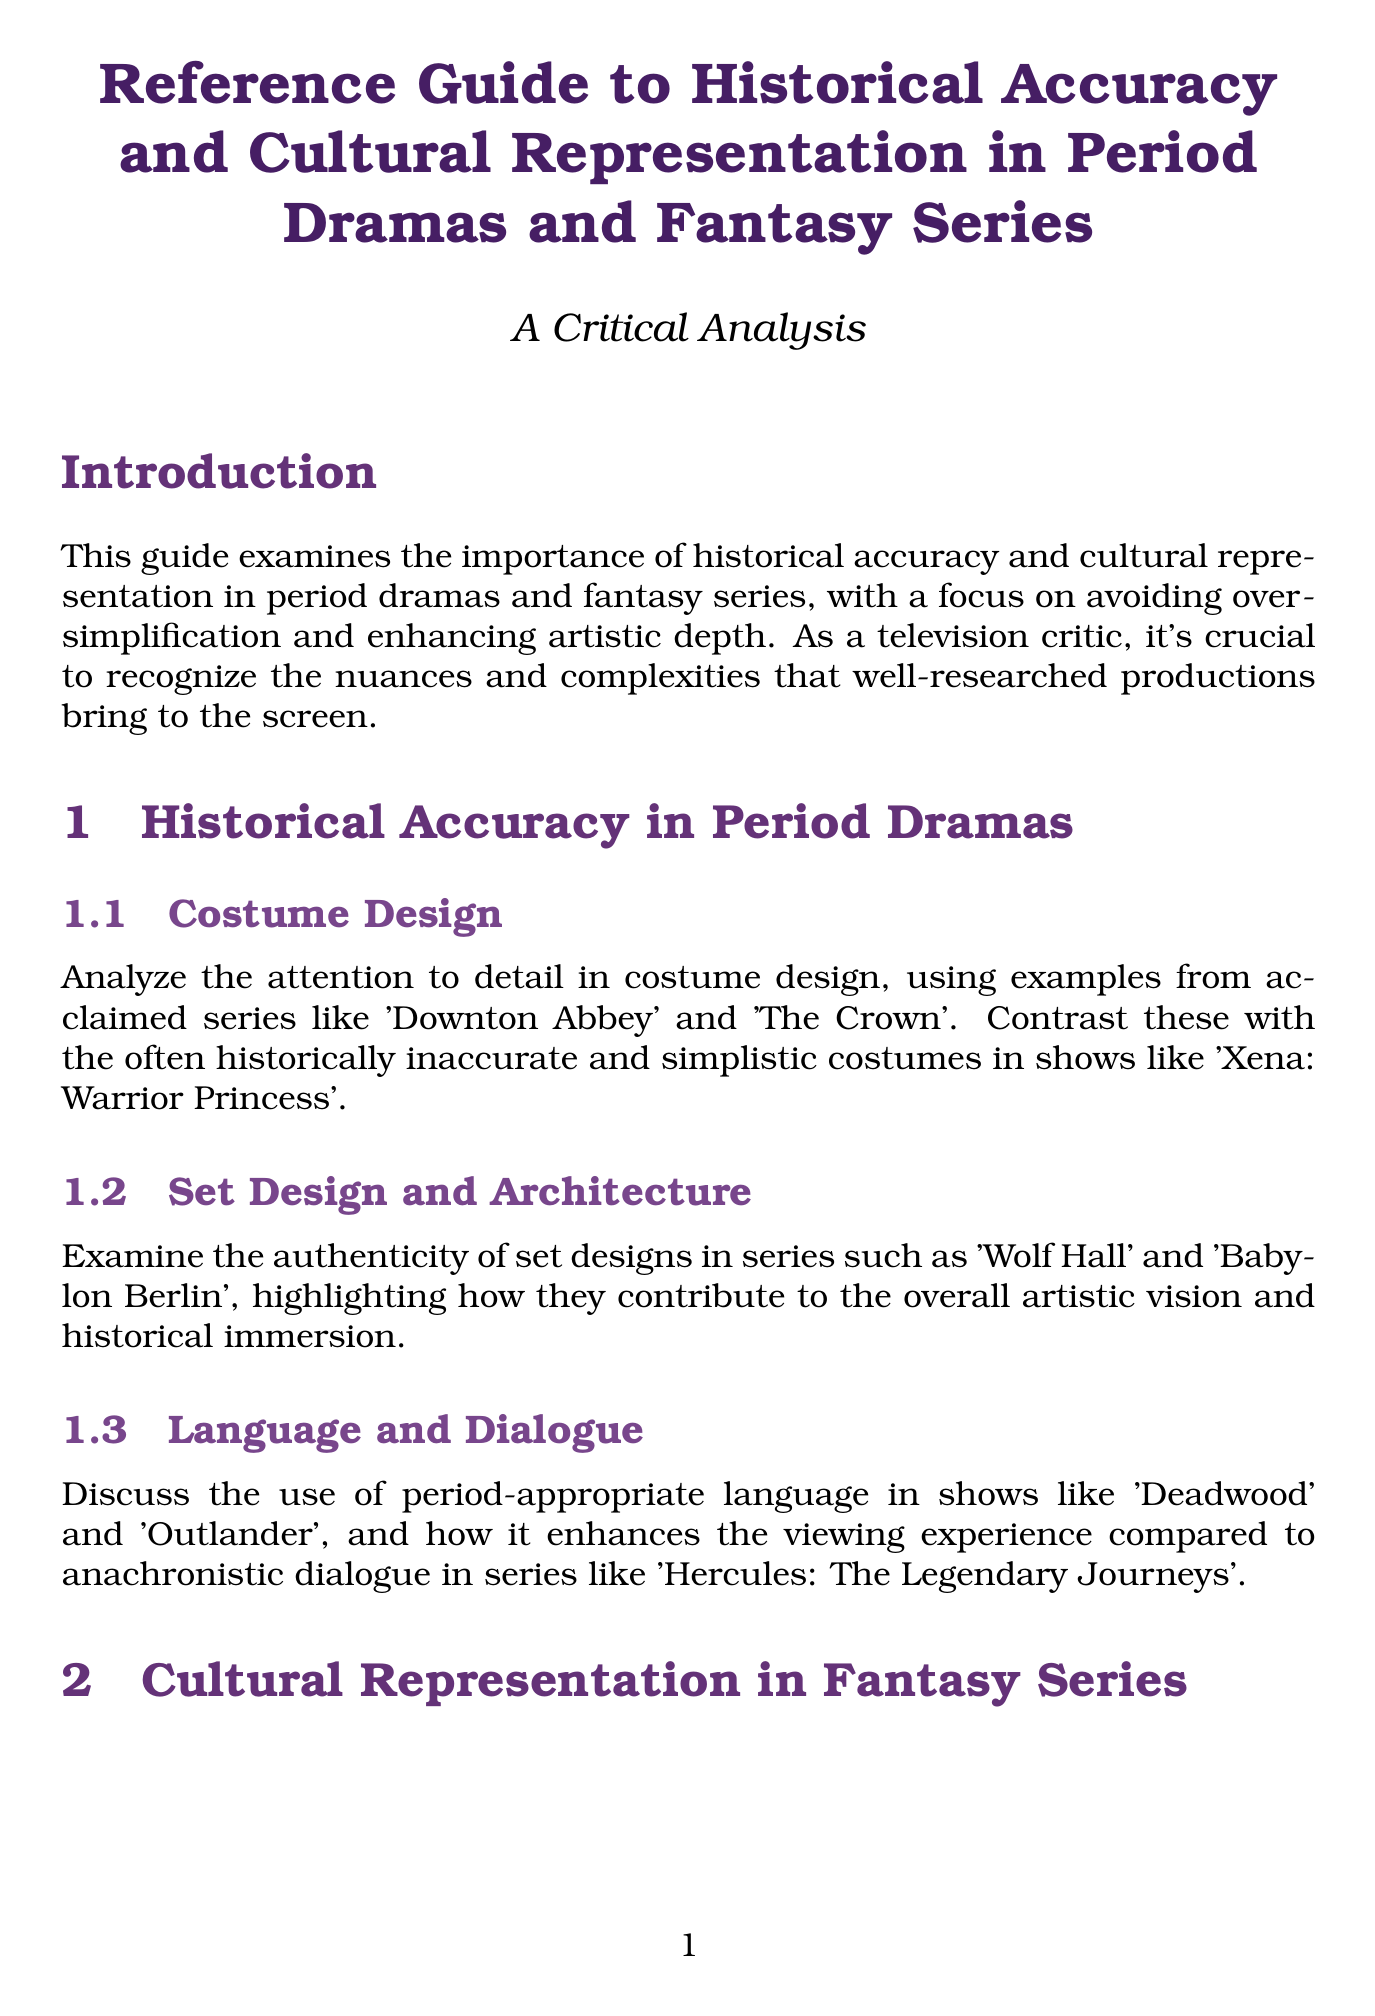What is the title of the guide? The title of the guide is stated at the top of the document.
Answer: Reference Guide to Historical Accuracy and Cultural Representation in Period Dramas and Fantasy Series Which series are mentioned as contrasting examples for costume design? The document lists specific series that are either acclaimed or criticized in terms of their costume design.
Answer: Xena: Warrior Princess What are two shows highlighted for their authenticity in set design? The section discusses specific shows that are renowned for their set designs.
Answer: Wolf Hall and Babylon Berlin What period-appropriate language series is referenced in the document? The phrase refers to historic language usage examined in the context of certain shows.
Answer: Deadwood Which fantasy series are analyzed for their depth of mythology? The analysis is specifically pointed towards series that have well-researched mythological elements.
Answer: American Gods and The Witcher What is emphasized as a benefit of diverse representation in fantasy series? The point highlights the narrative advantages of including diverse characters in storytelling.
Answer: Complexity to storytelling Which two shows are examples of balancing historical accuracy and creative license? This question requires knowledge of specific shows that exemplify this balance based on the document's content.
Answer: The Great and Dickinson What is a key purpose of the guide mentioned in the conclusion? The conclusion summarizes what the guide aims to emphasize regarding television series.
Answer: Artistically rich and intellectually stimulating How many sub-sections are there in the 'Cultural Representation in Fantasy Series' section? This question asks for a count of the subsections under the specified section of the guide.
Answer: Three 